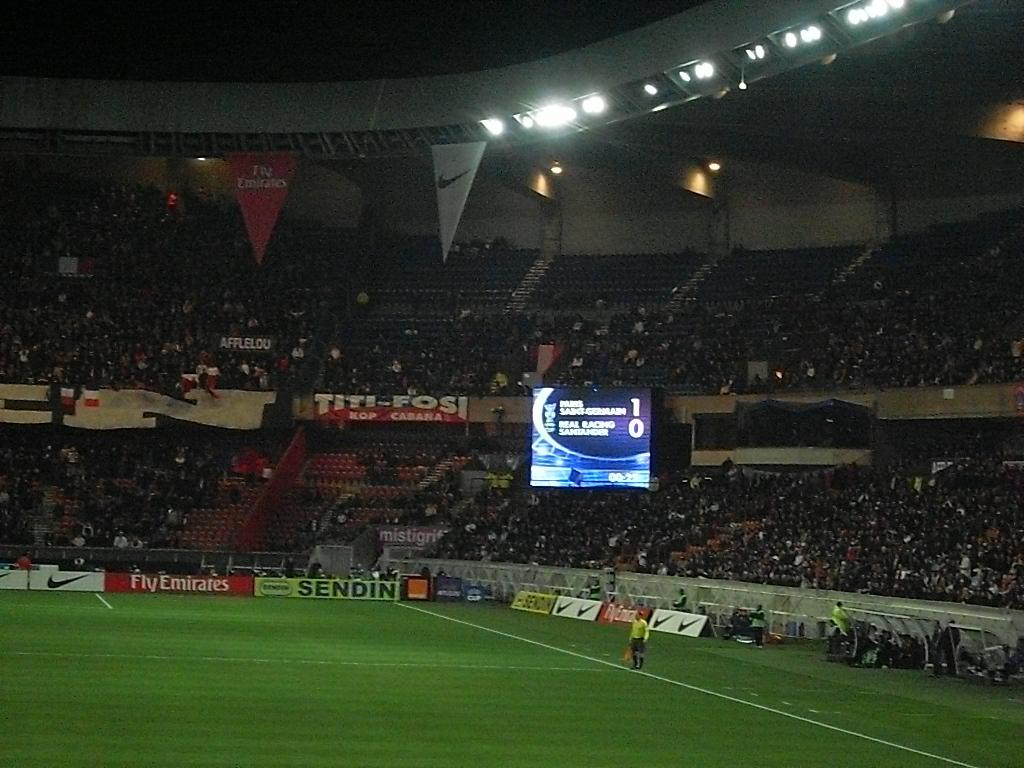<image>
Summarize the visual content of the image. A football stadium has a large screen showing the score at 1-0. 